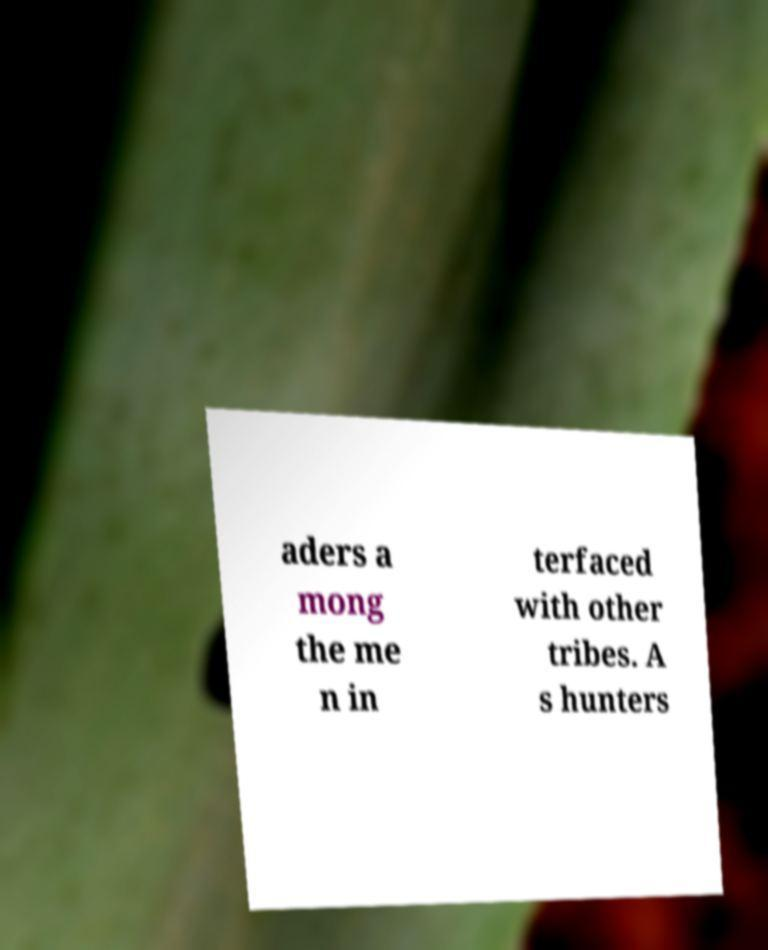Could you extract and type out the text from this image? aders a mong the me n in terfaced with other tribes. A s hunters 